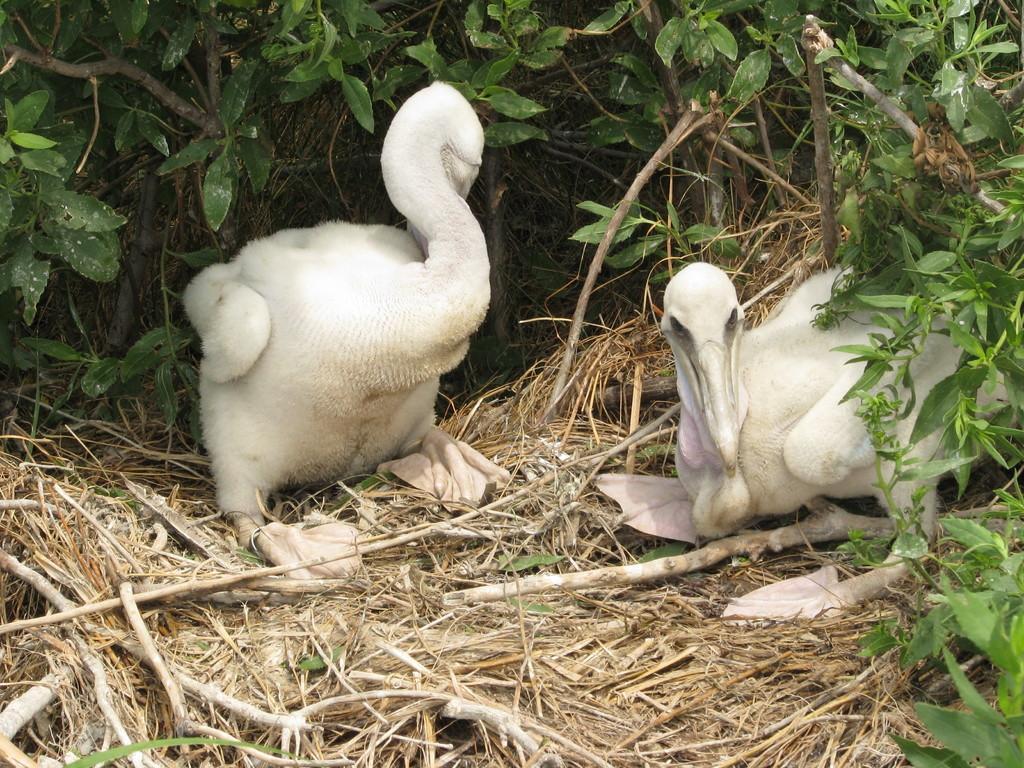How would you summarize this image in a sentence or two? Here we can see birds, dry grass, branches and leaves. 